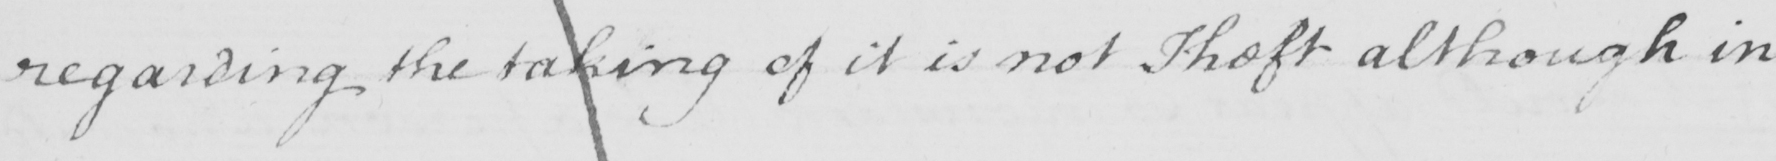What is written in this line of handwriting? regarding the taking of it is not Theft although in 